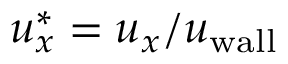<formula> <loc_0><loc_0><loc_500><loc_500>u _ { x } ^ { \ast } = u _ { x } / u _ { w a l l }</formula> 